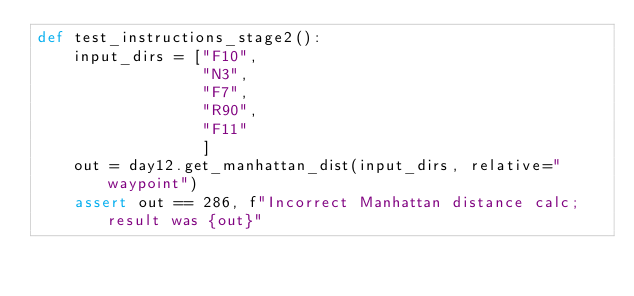Convert code to text. <code><loc_0><loc_0><loc_500><loc_500><_Python_>def test_instructions_stage2():
    input_dirs = ["F10",
                  "N3",
                  "F7",
                  "R90",
                  "F11"
                  ]
    out = day12.get_manhattan_dist(input_dirs, relative="waypoint")
    assert out == 286, f"Incorrect Manhattan distance calc; result was {out}"
</code> 